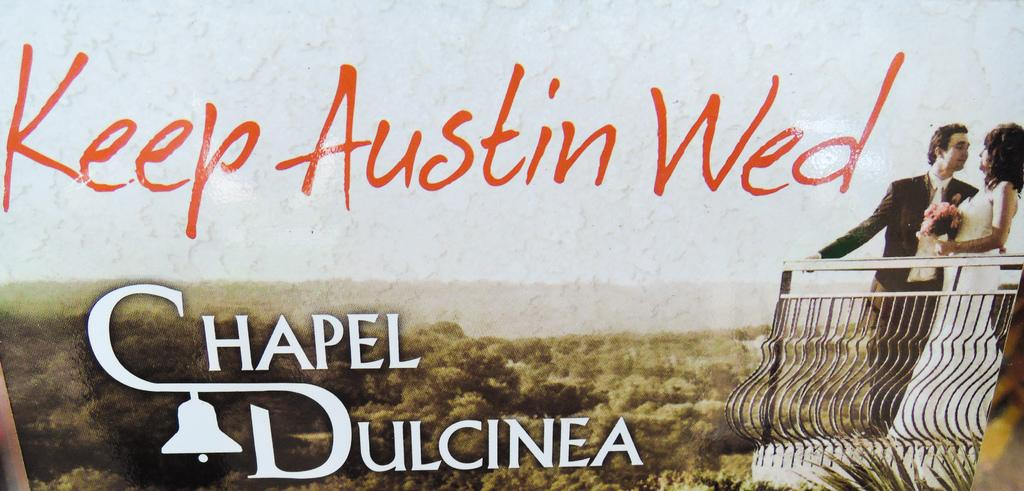What is depicted on the poster in the image? The poster contains a couple in the image. What is the couple doing in the poster? The couple is standing on the floor in the poster. Where are the couple located in relation to other objects in the poster? The couple is near railings in the poster. What type of truck can be seen in the image? There is no truck present in the image; it features a poster with a couple standing on the floor near railings. How many letters are visible on the camera in the image? There is no camera present in the image; it only contains a poster with a couple standing on the floor near railings. 